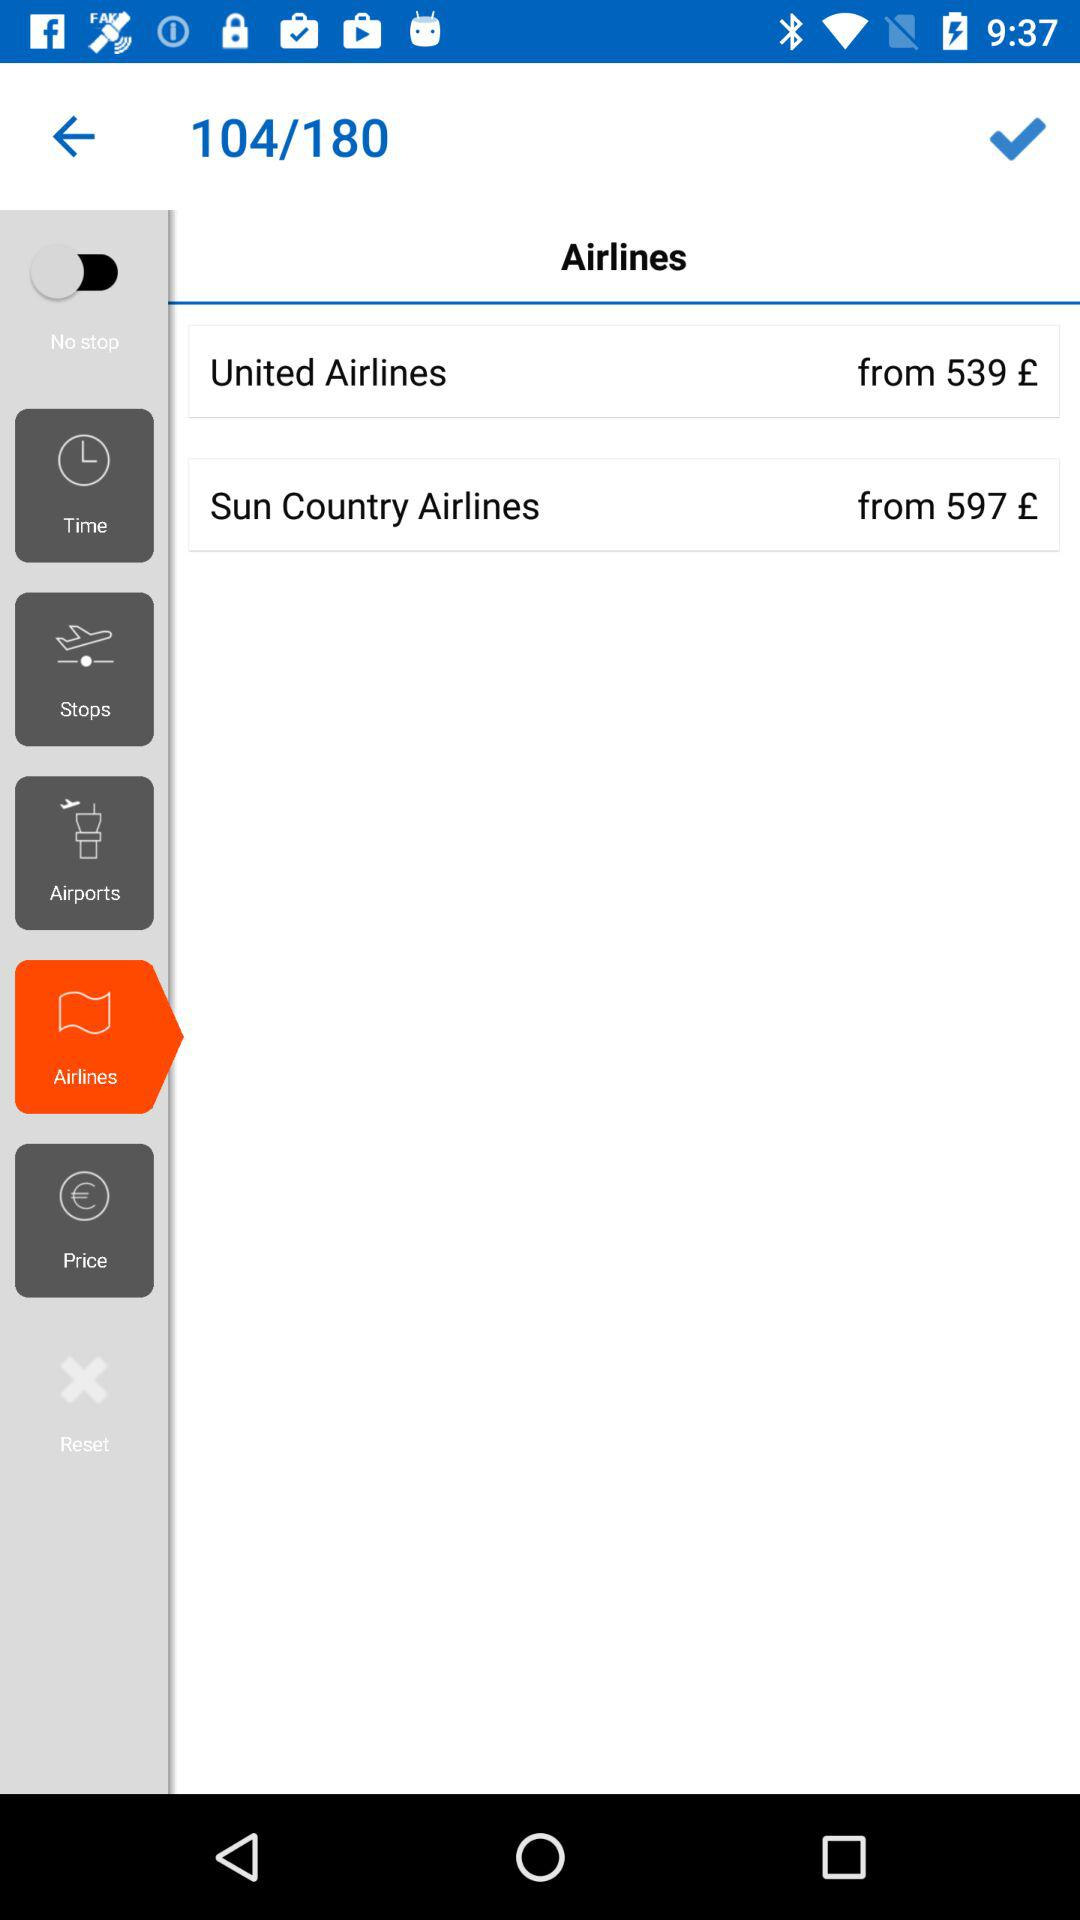THe currency What currency is used for the price? The currency used for the price is pounds. 